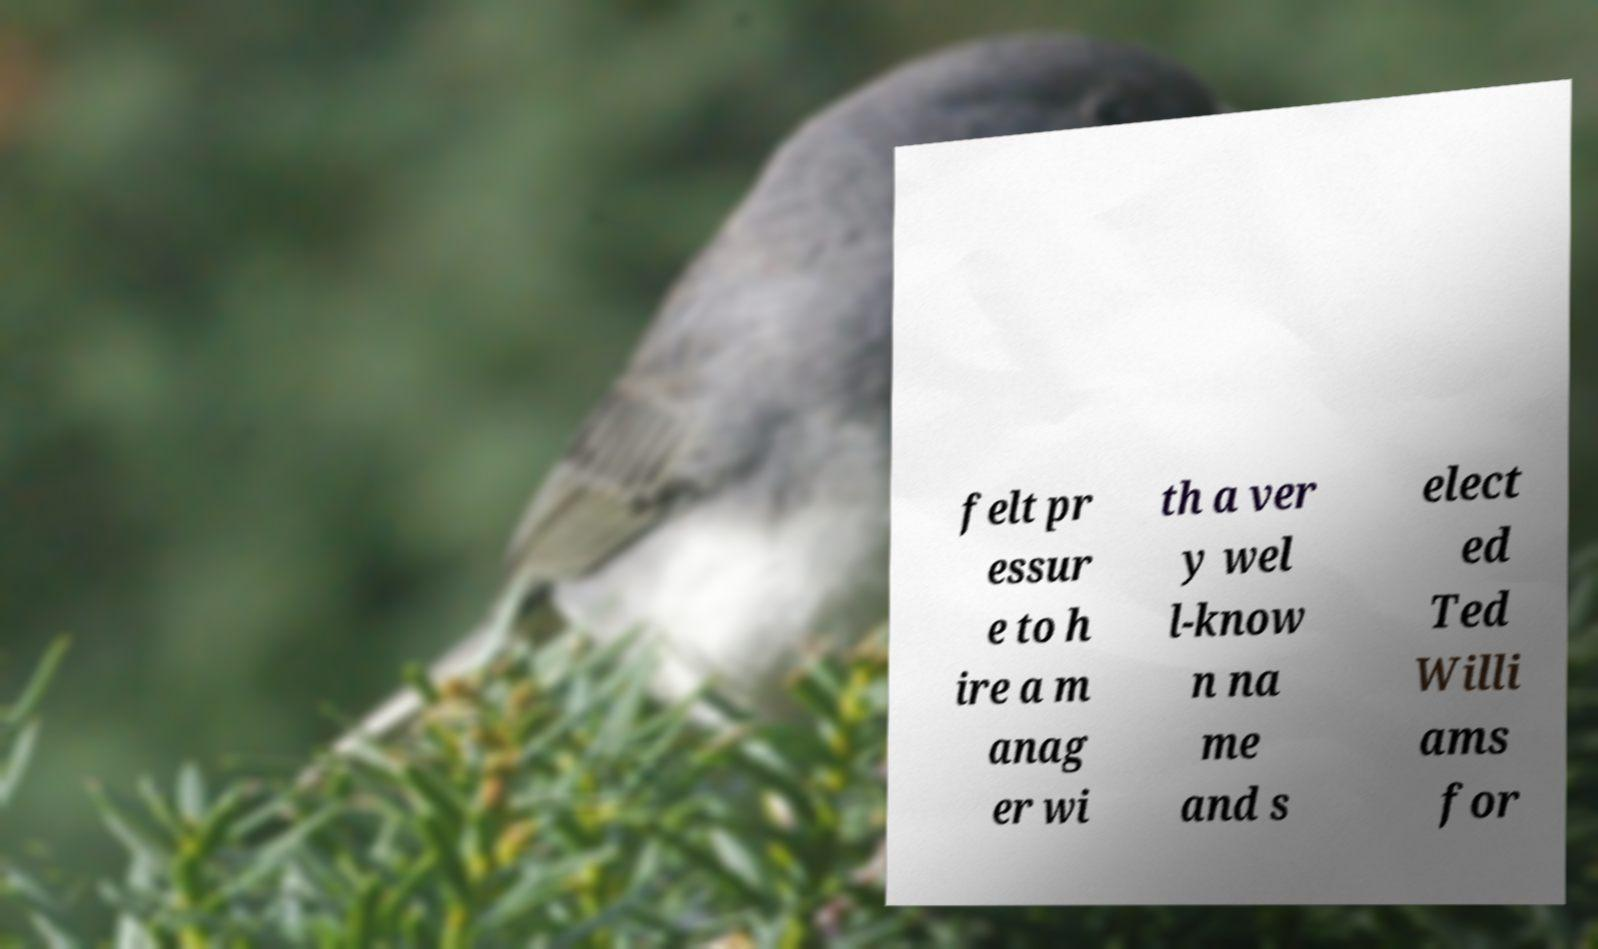Could you extract and type out the text from this image? felt pr essur e to h ire a m anag er wi th a ver y wel l-know n na me and s elect ed Ted Willi ams for 